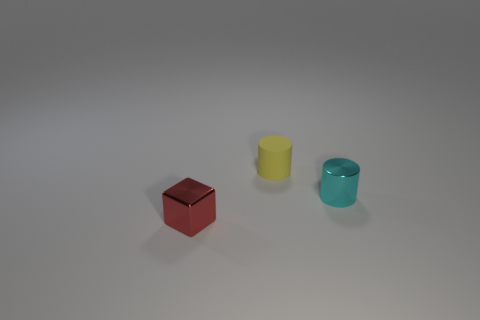Add 3 small yellow rubber balls. How many objects exist? 6 Subtract all cylinders. How many objects are left? 1 Subtract all tiny blue metal blocks. Subtract all tiny red metallic things. How many objects are left? 2 Add 2 tiny cyan cylinders. How many tiny cyan cylinders are left? 3 Add 1 red shiny cubes. How many red shiny cubes exist? 2 Subtract 0 green blocks. How many objects are left? 3 